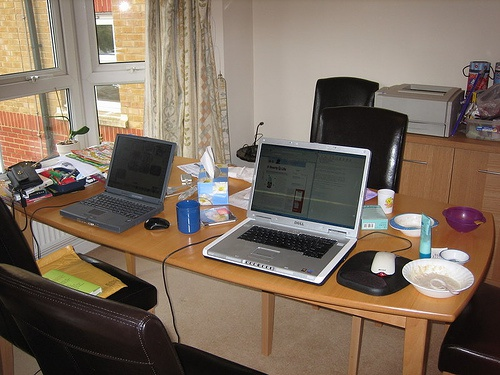Describe the objects in this image and their specific colors. I can see dining table in tan, brown, gray, lightgray, and black tones, laptop in tan, gray, black, darkgray, and lightgray tones, chair in tan, black, and gray tones, laptop in tan, black, gray, and purple tones, and chair in tan, black, gray, darkgray, and lightgray tones in this image. 